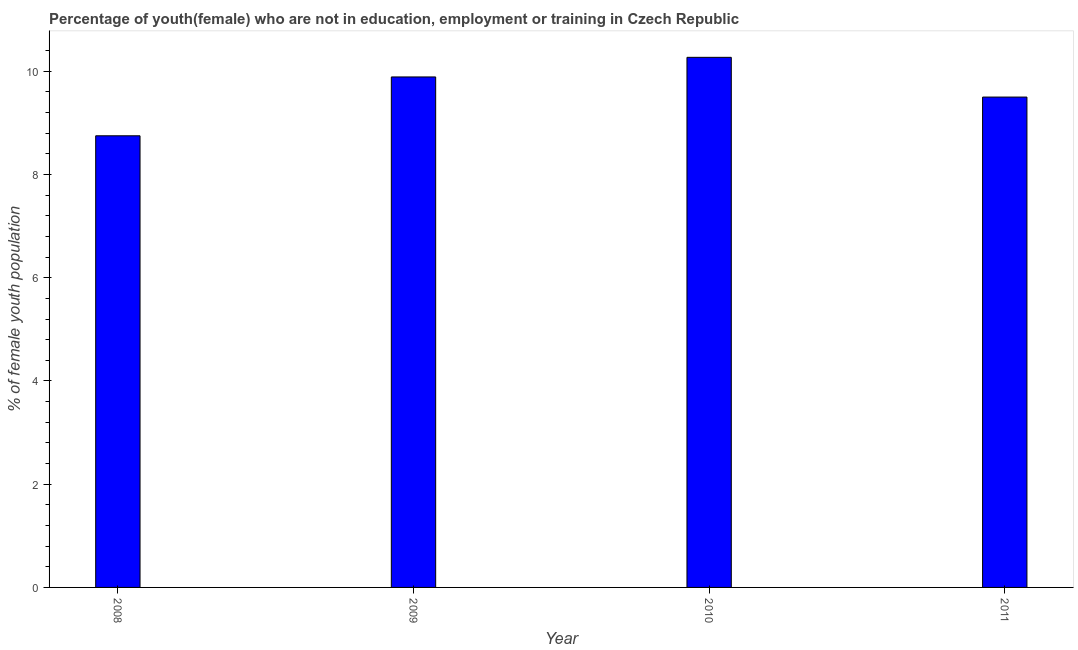Does the graph contain any zero values?
Ensure brevity in your answer.  No. Does the graph contain grids?
Offer a very short reply. No. What is the title of the graph?
Ensure brevity in your answer.  Percentage of youth(female) who are not in education, employment or training in Czech Republic. What is the label or title of the X-axis?
Keep it short and to the point. Year. What is the label or title of the Y-axis?
Your answer should be compact. % of female youth population. What is the unemployed female youth population in 2009?
Your answer should be compact. 9.89. Across all years, what is the maximum unemployed female youth population?
Ensure brevity in your answer.  10.27. Across all years, what is the minimum unemployed female youth population?
Keep it short and to the point. 8.75. What is the sum of the unemployed female youth population?
Keep it short and to the point. 38.41. What is the difference between the unemployed female youth population in 2009 and 2010?
Give a very brief answer. -0.38. What is the average unemployed female youth population per year?
Ensure brevity in your answer.  9.6. What is the median unemployed female youth population?
Your answer should be very brief. 9.7. In how many years, is the unemployed female youth population greater than 5.6 %?
Offer a terse response. 4. Do a majority of the years between 2008 and 2011 (inclusive) have unemployed female youth population greater than 6.4 %?
Offer a very short reply. Yes. What is the ratio of the unemployed female youth population in 2008 to that in 2009?
Your answer should be very brief. 0.89. What is the difference between the highest and the second highest unemployed female youth population?
Ensure brevity in your answer.  0.38. What is the difference between the highest and the lowest unemployed female youth population?
Make the answer very short. 1.52. Are all the bars in the graph horizontal?
Provide a succinct answer. No. How many years are there in the graph?
Ensure brevity in your answer.  4. What is the % of female youth population of 2008?
Your answer should be very brief. 8.75. What is the % of female youth population in 2009?
Give a very brief answer. 9.89. What is the % of female youth population in 2010?
Your answer should be compact. 10.27. What is the % of female youth population of 2011?
Make the answer very short. 9.5. What is the difference between the % of female youth population in 2008 and 2009?
Your response must be concise. -1.14. What is the difference between the % of female youth population in 2008 and 2010?
Your response must be concise. -1.52. What is the difference between the % of female youth population in 2008 and 2011?
Ensure brevity in your answer.  -0.75. What is the difference between the % of female youth population in 2009 and 2010?
Offer a terse response. -0.38. What is the difference between the % of female youth population in 2009 and 2011?
Provide a short and direct response. 0.39. What is the difference between the % of female youth population in 2010 and 2011?
Offer a very short reply. 0.77. What is the ratio of the % of female youth population in 2008 to that in 2009?
Keep it short and to the point. 0.89. What is the ratio of the % of female youth population in 2008 to that in 2010?
Your answer should be compact. 0.85. What is the ratio of the % of female youth population in 2008 to that in 2011?
Provide a short and direct response. 0.92. What is the ratio of the % of female youth population in 2009 to that in 2010?
Offer a terse response. 0.96. What is the ratio of the % of female youth population in 2009 to that in 2011?
Your answer should be compact. 1.04. What is the ratio of the % of female youth population in 2010 to that in 2011?
Make the answer very short. 1.08. 